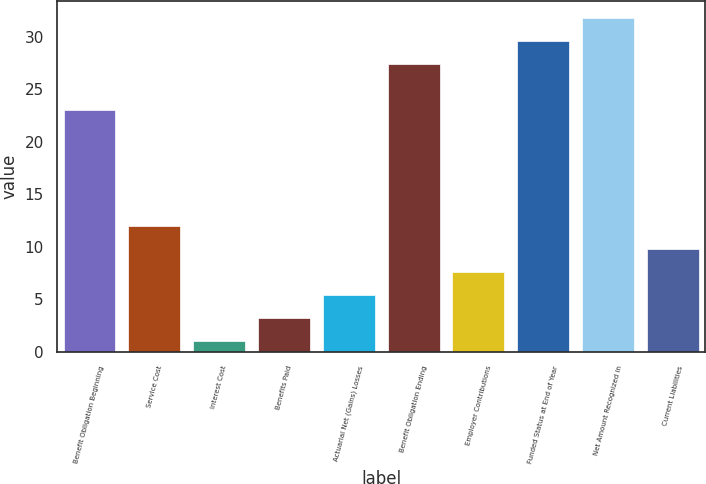Convert chart to OTSL. <chart><loc_0><loc_0><loc_500><loc_500><bar_chart><fcel>Benefit Obligation Beginning<fcel>Service Cost<fcel>Interest Cost<fcel>Benefits Paid<fcel>Actuarial Net (Gains) Losses<fcel>Benefit Obligation Ending<fcel>Employer Contributions<fcel>Funded Status at End of Year<fcel>Net Amount Recognized in<fcel>Current Liabilities<nl><fcel>23<fcel>12<fcel>1<fcel>3.2<fcel>5.4<fcel>27.4<fcel>7.6<fcel>29.6<fcel>31.8<fcel>9.8<nl></chart> 